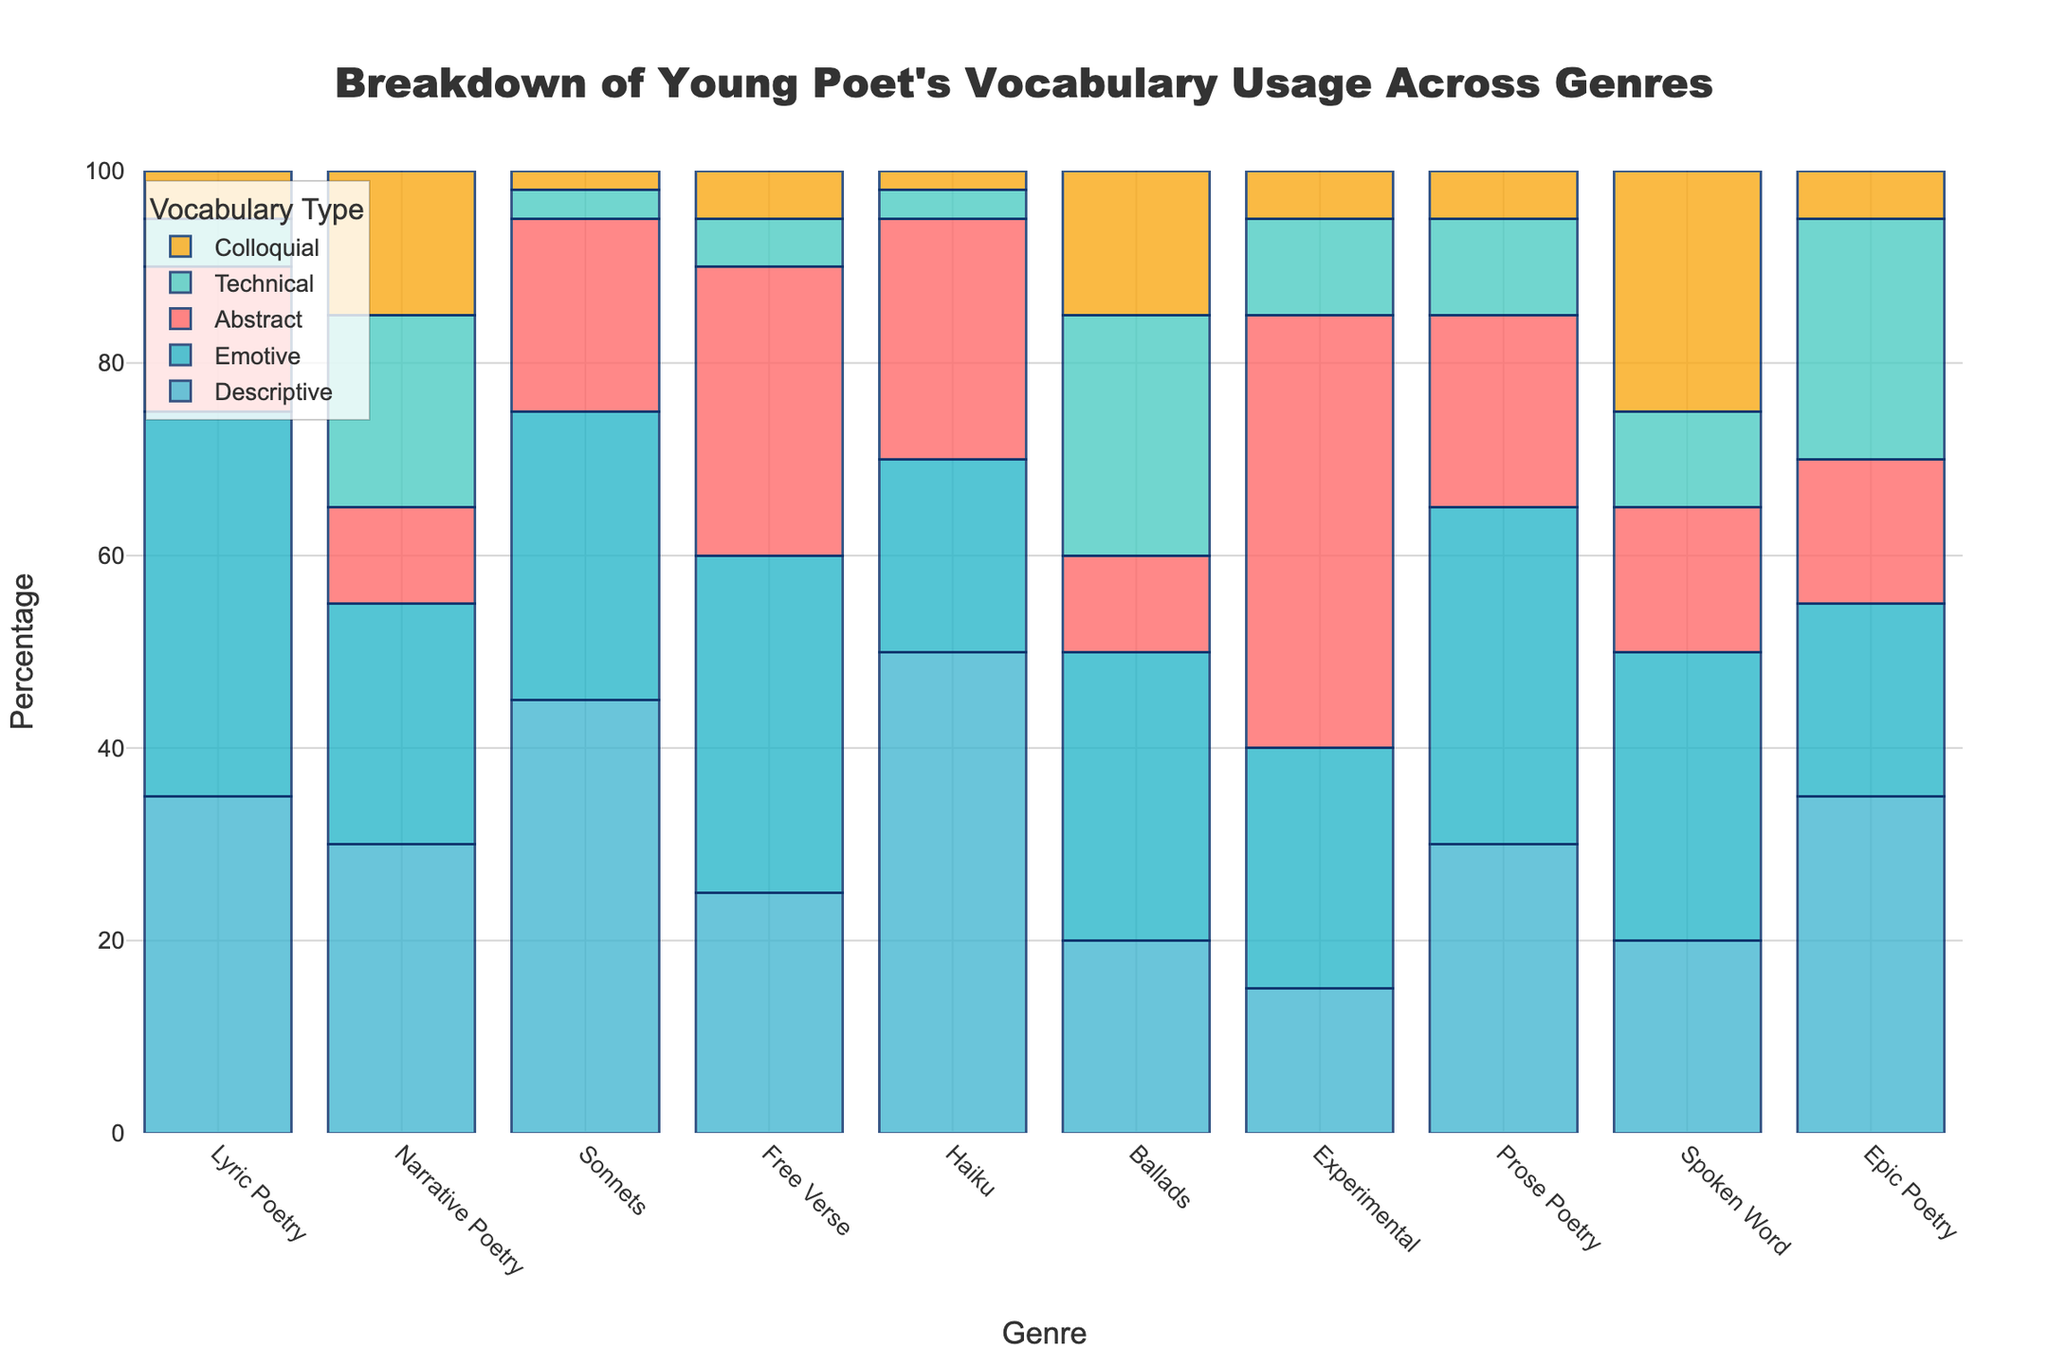Which genre uses the highest percentage of descriptive vocabulary? Look at the bar heights across all genres for the descriptive vocabulary type and identify the tallest one. Lyric poetry has 35% while Haiku has 50%.
Answer: Haiku Which genre shows the most balanced distribution across all vocabulary types? Identify the genre where the bars for each vocabulary type are closest in height. The genre with the most balanced distribution is Spoken Word, where the percentages range from 10% to 30%.
Answer: Spoken Word What is the difference in the percentage of technical vocabulary between Epic Poetry and Ballads? Epic Poetry uses 25% of technical vocabulary while Ballads use 25%. Calculate the difference: 25% - 25% = 0%.
Answer: 0% Which genre has the least usage of colloquial vocabulary? Examine the bar heights for colloquial vocabulary across all genres and identify the lowest one. Both Haiku and Sonnets use 2% colloquial vocabulary, which is the least.
Answer: Haiku, Sonnets How does the usage of emotive vocabulary in Free Verse compare to that in Narrative Poetry? Compare the bar heights for emotive vocabulary in Free Verse (35%) and Narrative Poetry (25%). Free Verse has a higher percentage of emotive vocabulary.
Answer: Free Verse has higher emotive vocabulary What is the combined percentage of abstract vocabulary in Sonnets and Haiku? Add the percentages of abstract vocabulary in Sonnets (20%) and Haiku (25%): 20% + 25% = 45%.
Answer: 45% Which genre uses emotive vocabulary more than abstract vocabulary by the largest difference? Calculate the difference between emotive and abstract vocabulary for each genre and identify the largest difference. Lyric Poetry has the largest difference: 40% - 15% = 25%.
Answer: Lyric Poetry Is the usage of descriptive vocabulary in Experimental lower than the usage of abstract vocabulary in the same genre? Compare the percentage for descriptive (15%) and abstract vocabulary (45%) in Experimental. Descriptive is lower.
Answer: Yes What is the average usage of technical vocabulary across all genres? Sum up the percentages of technical vocabulary across all genres and divide by the number of genres. (5 + 20 + 3 + 5 + 3 + 25 + 10 + 10 + 10 + 25)/10 = 11.6%.
Answer: 11.6% Which genre has the most significant usage of a single vocabulary type, and what type is it? Identify the highest bar across all genres and vocabulary types. Experimental uses 45% abstract vocabulary.
Answer: Experimental, abstract 